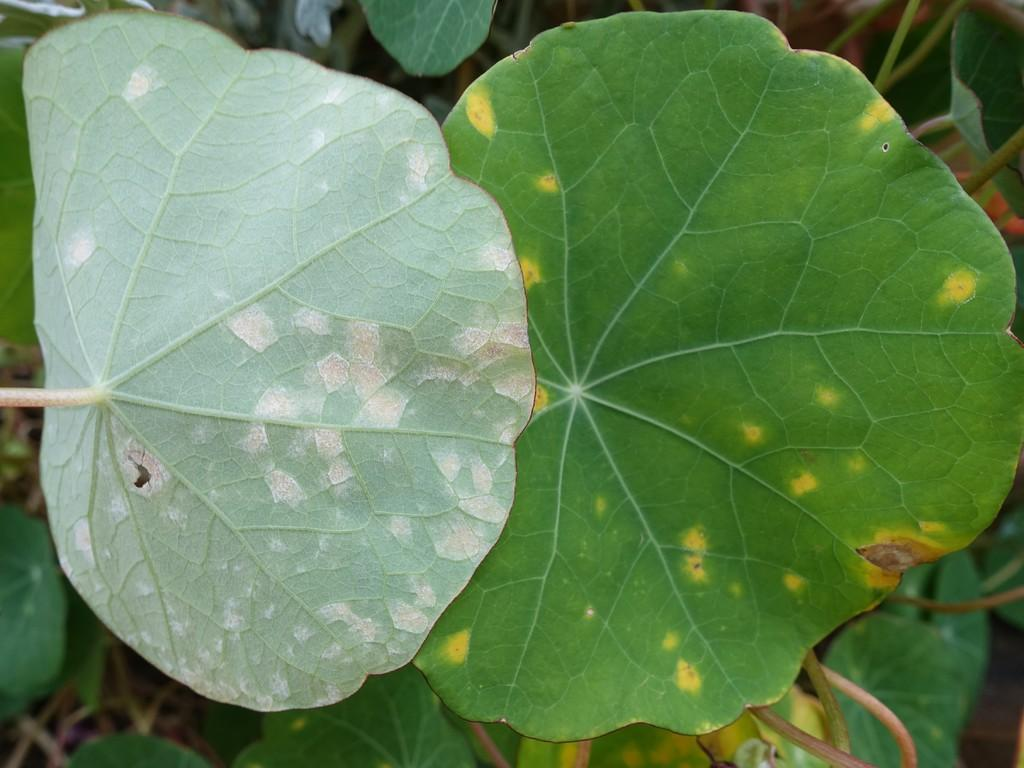What color are the leaves in the image? The leaves in the image are green with yellow color patches. Can you describe the appearance of the leaves in more detail? Yes, the leaves have yellow patches on them. What can be seen in the background of the image? There are plants in the background of the image. Reasoning: Let's think step by breaking down the conversation step by step. We start by identifying the main subject of the image, which are the leaves. We then provide more detail about the leaves by mentioning the yellow color patches. Finally, we expand the conversation to include the background of the image, which features plants. Absurd Question/Answer: How many money bills can be seen in the image? There are no money bills present in the image; it features leaves with yellow patches and plants in the background. How many firemen are visible in the image? There are no firemen present in the image; it features leaves with yellow patches and plants in the background. 